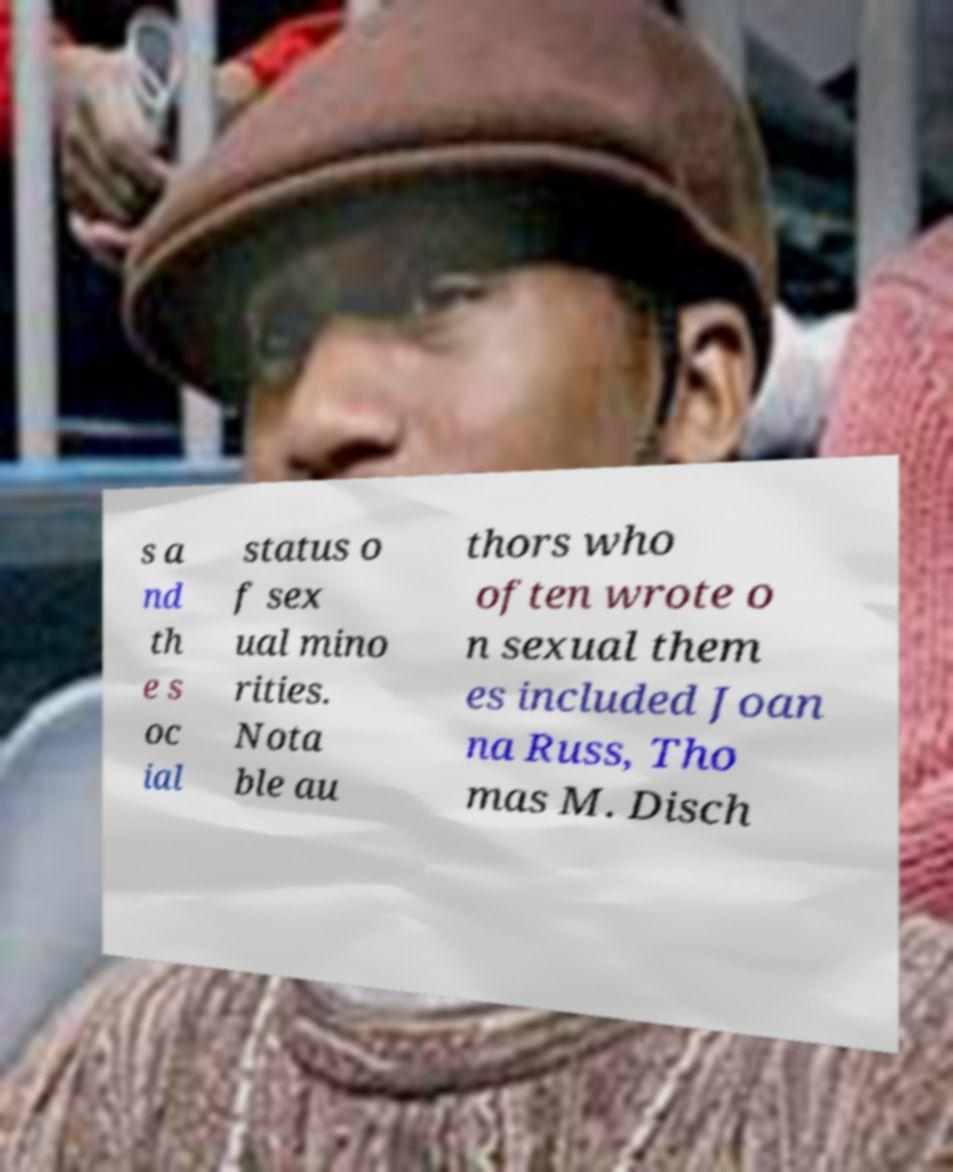For documentation purposes, I need the text within this image transcribed. Could you provide that? s a nd th e s oc ial status o f sex ual mino rities. Nota ble au thors who often wrote o n sexual them es included Joan na Russ, Tho mas M. Disch 